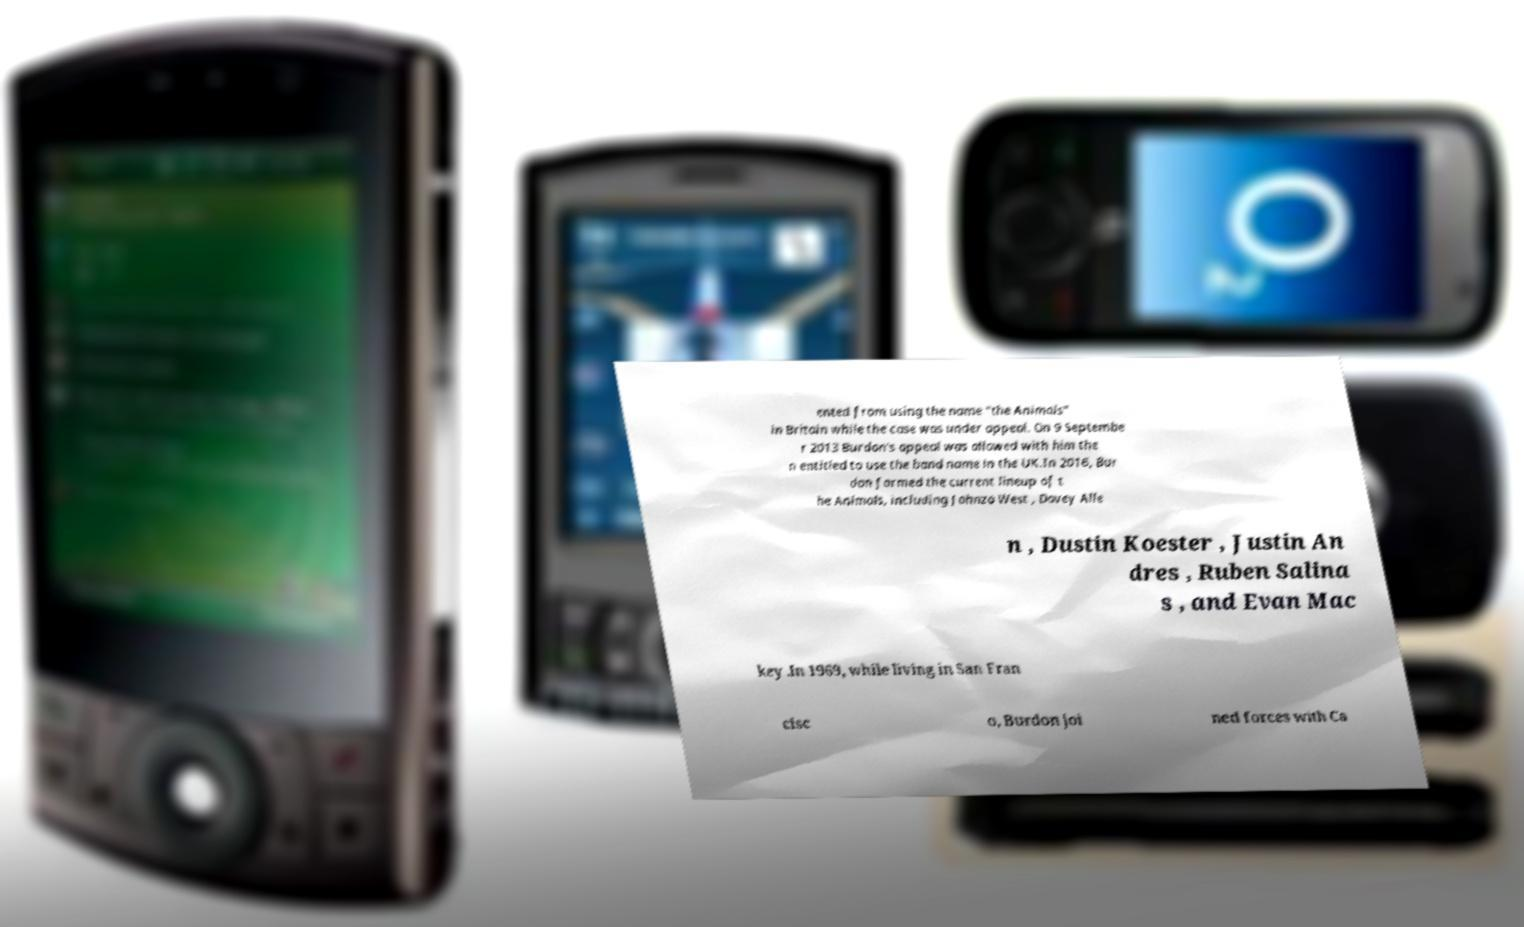Please identify and transcribe the text found in this image. ented from using the name "the Animals" in Britain while the case was under appeal. On 9 Septembe r 2013 Burdon's appeal was allowed with him the n entitled to use the band name in the UK.In 2016, Bur don formed the current lineup of t he Animals, including Johnzo West , Davey Alle n , Dustin Koester , Justin An dres , Ruben Salina s , and Evan Mac key .In 1969, while living in San Fran cisc o, Burdon joi ned forces with Ca 